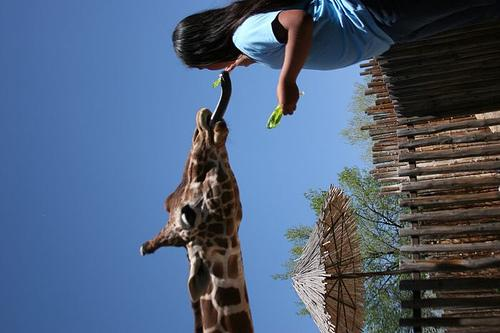List the primary colors seen in the image and the objects they are associated with. Blue: girl's shirt and sky, Brown: giraffe, girl's hair, fence, and tree, White: giraffe spots, Green: lettuce. Highlight the most noticeable aspect of the girl and the giraffe's interaction in the photo. The most noticeable aspect is the giraffe sticking out its long tongue to take the lettuce from the girl's hand, while the girl feeds the giraffe happily. Describe the appearance of the girl and her actions in the image. The girl has long, straight black hair and is wearing a blue short sleeve shirt. She is feeding lettuce to a giraffe with her hands. Mention the objects in the background of the image and their characteristics. There is a brown wooden fence running across, a clear blue sky without any clouds, and further back are trees with colored leaves. Describe the setting where the image has been captured. The image is captured outdoors on a sunny day, with a clear blue sky, behind a wooden fence, possibly at a zoo or a park. Briefly describe the main subject's attire and appearance in the picture. The main subject, the girl, is wearing a blue short sleeve shirt, and has long, straight, black hair flowing down her back. Identify the animals in the picture and describe their coloration and behavior. There is a giraffe with brown and white spots, extending its neck and sticking out its long tongue to eat, while a girl with long hair feeds it. Mention the significant elements in the image that contribute to its overall mood or atmosphere. The clear blue sky, extending giraffe's neck, smiling girl's interaction, and the wooden fence create a lively and joyful atmosphere in the picture. Mention the key objects in the image and their notable features. A giraffe with horns and long tongue being fed by a little girl with long black hair wearing a blue short sleeve shirt, with a wooden fence and clear blue sky in the background. Discuss the interaction between the girl and the giraffe in the photo. The girl is feeding the giraffe some food in her hand and the giraffe is sticking out its long tongue to grab it, creating a moment of connection between them. 